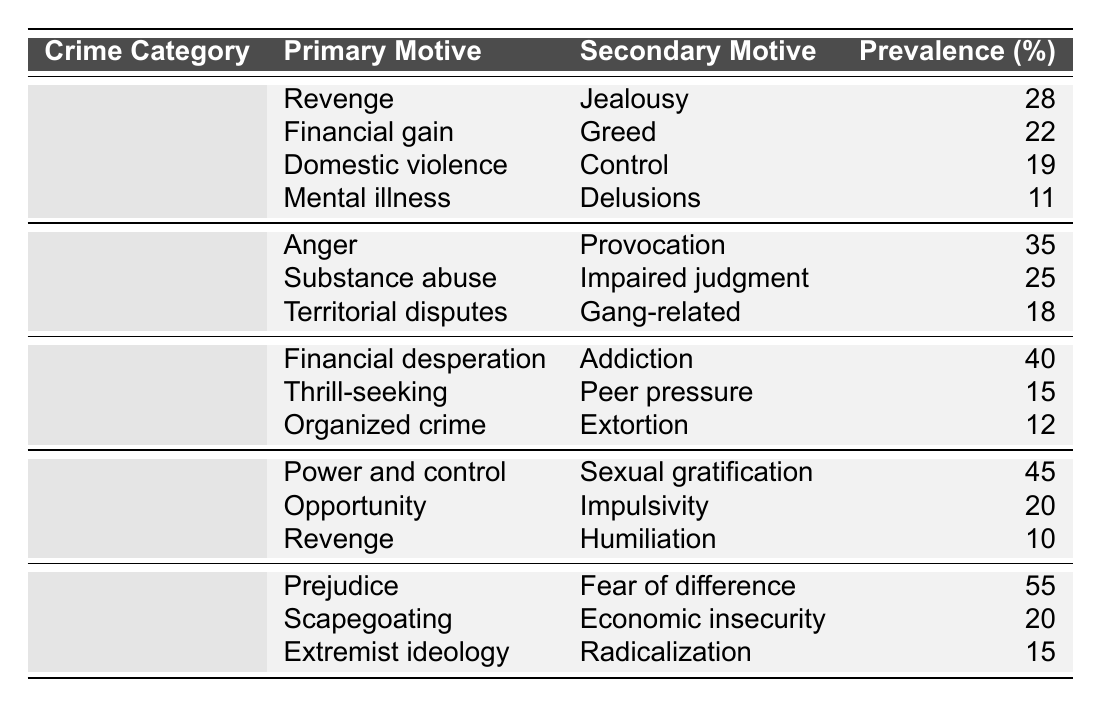What is the primary motive for robbery with the highest prevalence? The table shows that "Financial desperation" is listed as the primary motive for robbery with a prevalence of 40%, which is the highest among the motives for robbery.
Answer: Financial desperation Which crime category has the highest prevalence of primary motives related to power dynamics? The "Sexual assault" category lists "Power and control" as the primary motive with a prevalence of 45%, which indicates it has the highest prevalence related to power dynamics.
Answer: Sexual assault What percentage of sexual assaults are motivated by revenge? According to the table, "Revenge" is listed as a primary motive for sexual assault with a prevalence of 10%.
Answer: 10% Which crime category has the lowest prevalence for its primary motives? By reviewing the table, "Homicide" has the lowest prevalence for its primary motive, which is "Mental illness" at 11%.
Answer: Homicide If we sum the prevalence percentages for the secondary motives of hate crimes, what do we get? The secondary motives for hate crimes are "Fear of difference" (20%), "Economic insecurity" (20%), and "Radicalization" (15%). Summing these gives 20 + 20 + 15 = 55.
Answer: 55 Is the primary motive of "Revenge" found in any other crime category besides homicide? Checking the table reveals that "Revenge" is also a primary motive listed under "Sexual assault", confirming that it is found in another category.
Answer: Yes What is the average prevalence of the primary motives for assault? The primary motives for assault are "Anger" (35%), "Substance abuse" (25%), and "Territorial disputes" (18%). The total prevalence is 35 + 25 + 18 = 78, and since there are 3 motives, the average is 78 / 3 = 26.
Answer: 26 Which motive for robbery follows "Financial desperation" in terms of prevalence? According to the table, the motive following "Financial desperation" (40%) is "Thrill-seeking," which has a prevalence of 15%.
Answer: Thrill-seeking How many crime categories list "Jealousy" as a primary motive? Referring to the table, "Jealousy" is a primary motive only under "Homicide," meaning it appears in one crime category.
Answer: 1 What is the difference in prevalence between the primary motives for sexual assault and hate crime? The primary motive for sexual assault is "Power and control" at 45%, and for hate crime, it is "Prejudice" at 55%. The difference is 55 - 45 = 10.
Answer: 10 